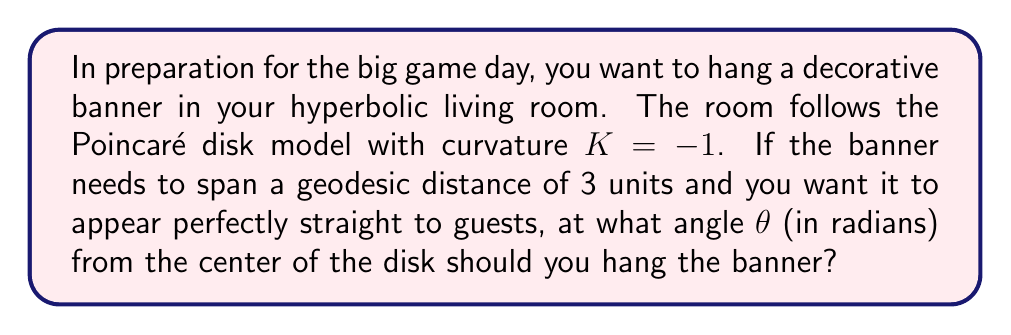Can you answer this question? Let's approach this step-by-step:

1) In the Poincaré disk model, geodesics appear as circular arcs perpendicular to the boundary of the disk (or as diameters).

2) For a geodesic to appear straight to observers in hyperbolic space, it must be a diameter of the Poincaré disk.

3) The hyperbolic distance $d$ between two points on a diameter of the Poincaré disk is given by:

   $$d = 2 \tanh^{-1}(r)$$

   where $r$ is the Euclidean distance from the center of the disk to the point.

4) We're given that $d = 3$ and we need to find $r$:

   $$3 = 2 \tanh^{-1}(r)$$
   $$\frac{3}{2} = \tanh^{-1}(r)$$
   $$r = \tanh(\frac{3}{2})$$

5) Now, we need to find the angle $\theta$ that corresponds to this $r$. In the Poincaré disk model, the relation between the hyperbolic angle $\theta$ and the Euclidean radius $r$ is:

   $$\theta = 2 \tan^{-1}(r)$$

6) Substituting our value of $r$:

   $$\theta = 2 \tan^{-1}(\tanh(\frac{3}{2}))$$

This is our final answer in radians.

[asy]
import geometry;

unitsize(100);
draw(circle((0,0),1));
draw((0,0)--(0.905,0));
draw(arc((0,0),0.4,(0,0),(0.905,0)),Arrow);
label("$\theta$",(0.2,0.1));
label("$r$",(0.45,0.05));
[/asy]
Answer: $\theta = 2 \tan^{-1}(\tanh(\frac{3}{2}))$ radians 